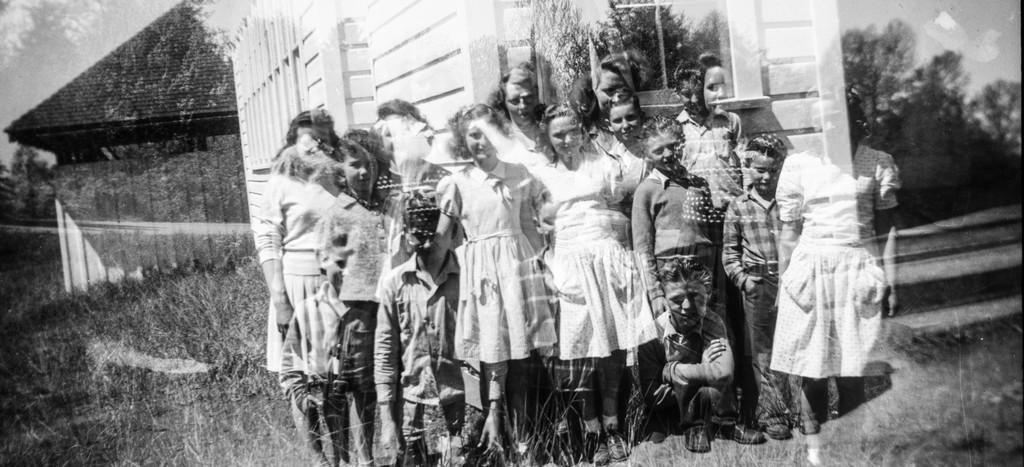Could you give a brief overview of what you see in this image? In this picture, i see few people standing and couple of buildings on the back and i see trees and grass on the ground 